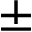<formula> <loc_0><loc_0><loc_500><loc_500>\pm</formula> 